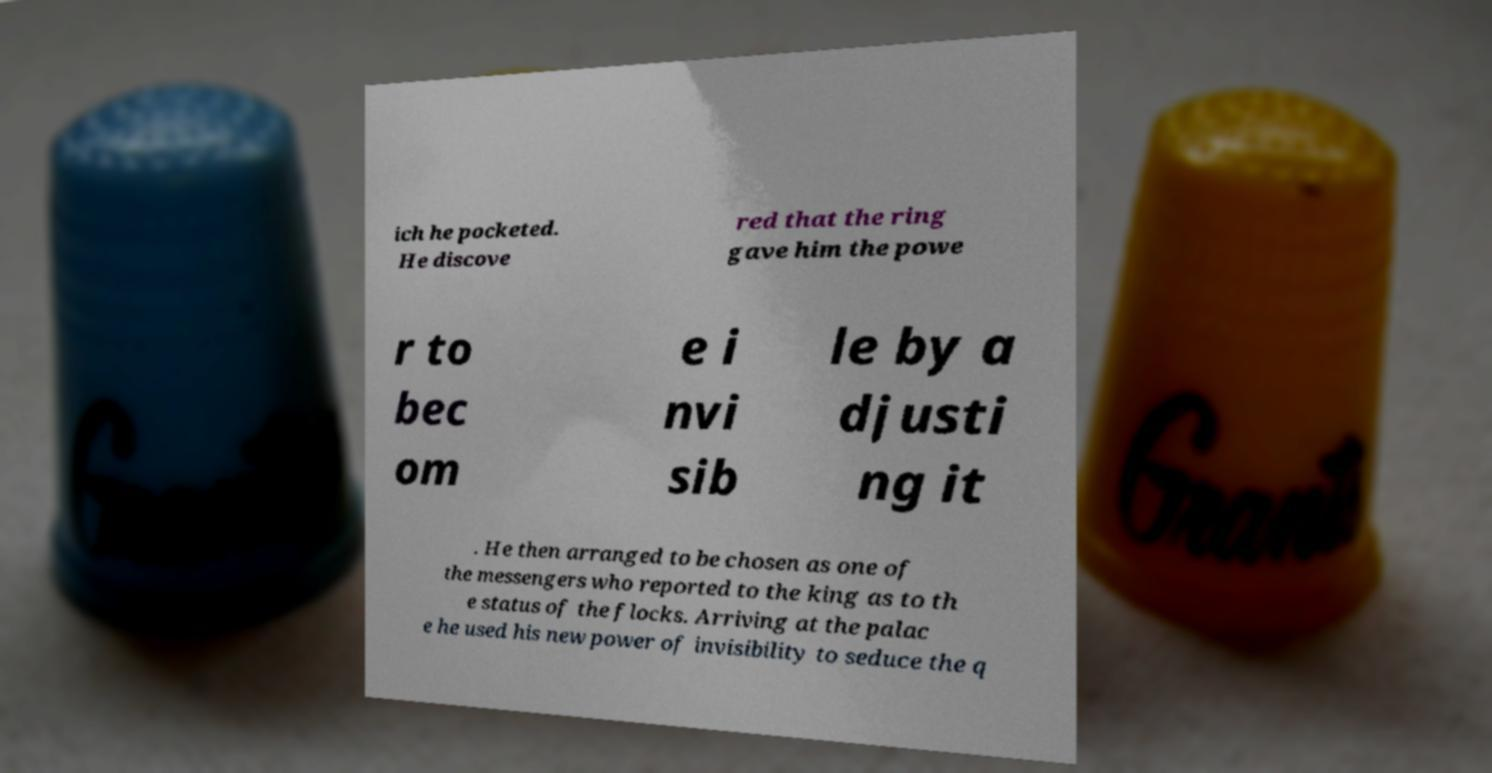Can you read and provide the text displayed in the image?This photo seems to have some interesting text. Can you extract and type it out for me? ich he pocketed. He discove red that the ring gave him the powe r to bec om e i nvi sib le by a djusti ng it . He then arranged to be chosen as one of the messengers who reported to the king as to th e status of the flocks. Arriving at the palac e he used his new power of invisibility to seduce the q 